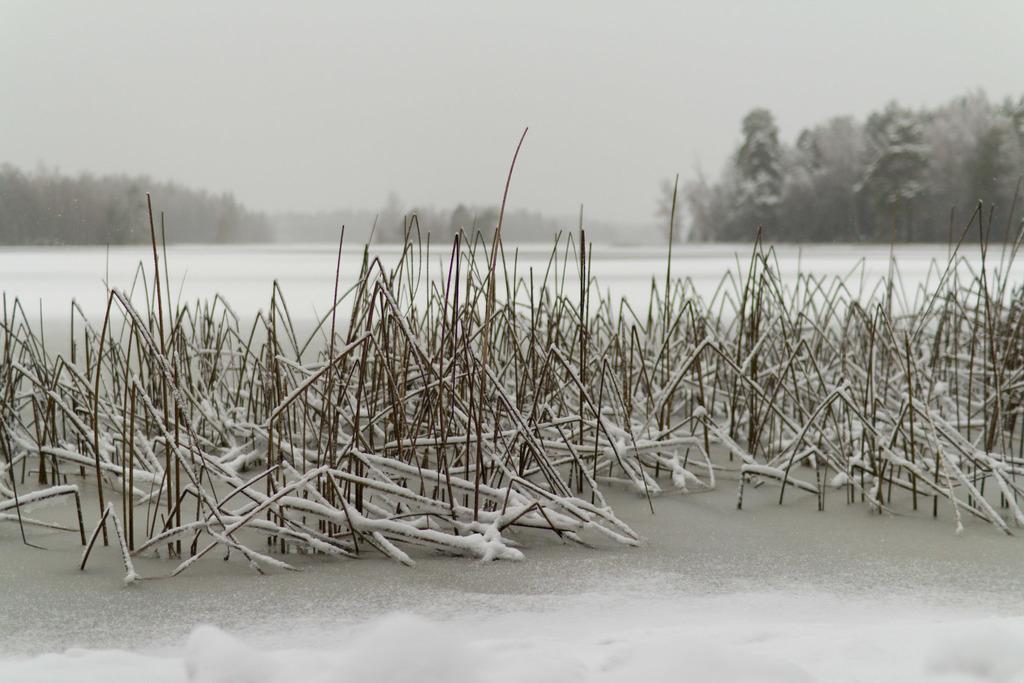Can you describe this image briefly? In the picture we can see a snow surface with dried grass and in the background, we can see some plants, trees, fog and sky. 